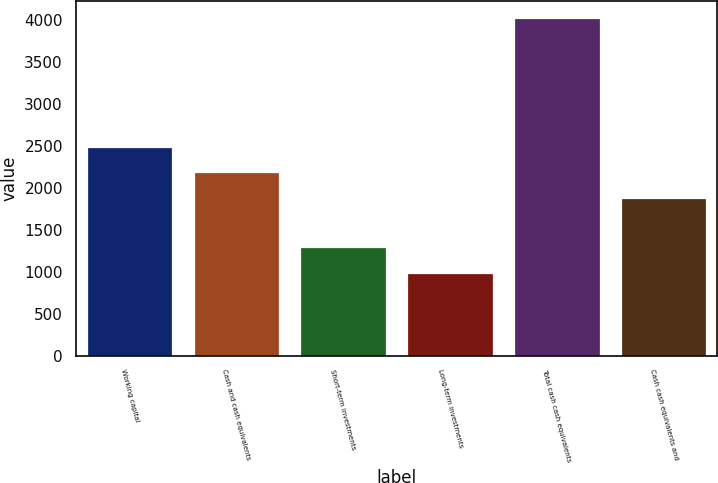<chart> <loc_0><loc_0><loc_500><loc_500><bar_chart><fcel>Working capital<fcel>Cash and cash equivalents<fcel>Short-term investments<fcel>Long-term investments<fcel>Total cash cash equivalents<fcel>Cash cash equivalents and<nl><fcel>2491.22<fcel>2187.96<fcel>1291.66<fcel>988.4<fcel>4021<fcel>1884.7<nl></chart> 